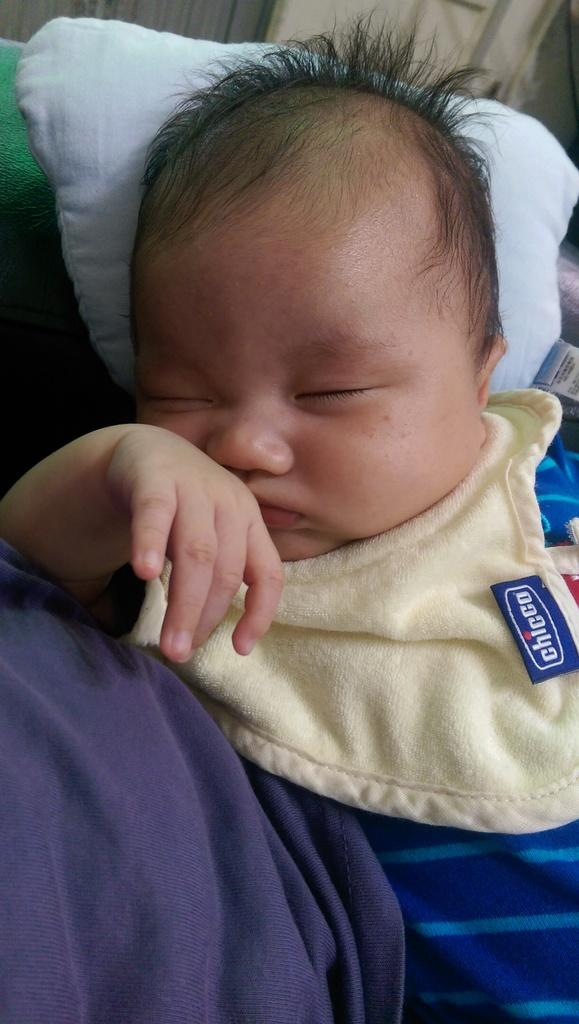What is the main subject of the image? There is a baby sleeping in the image. What else can be seen in the image besides the baby? There are clothes visible in the image. What is in the background of the image? There is a wall in the background of the image. What type of holiday is the baby celebrating in the image? There is no indication of a holiday in the image; it simply shows a baby sleeping. 